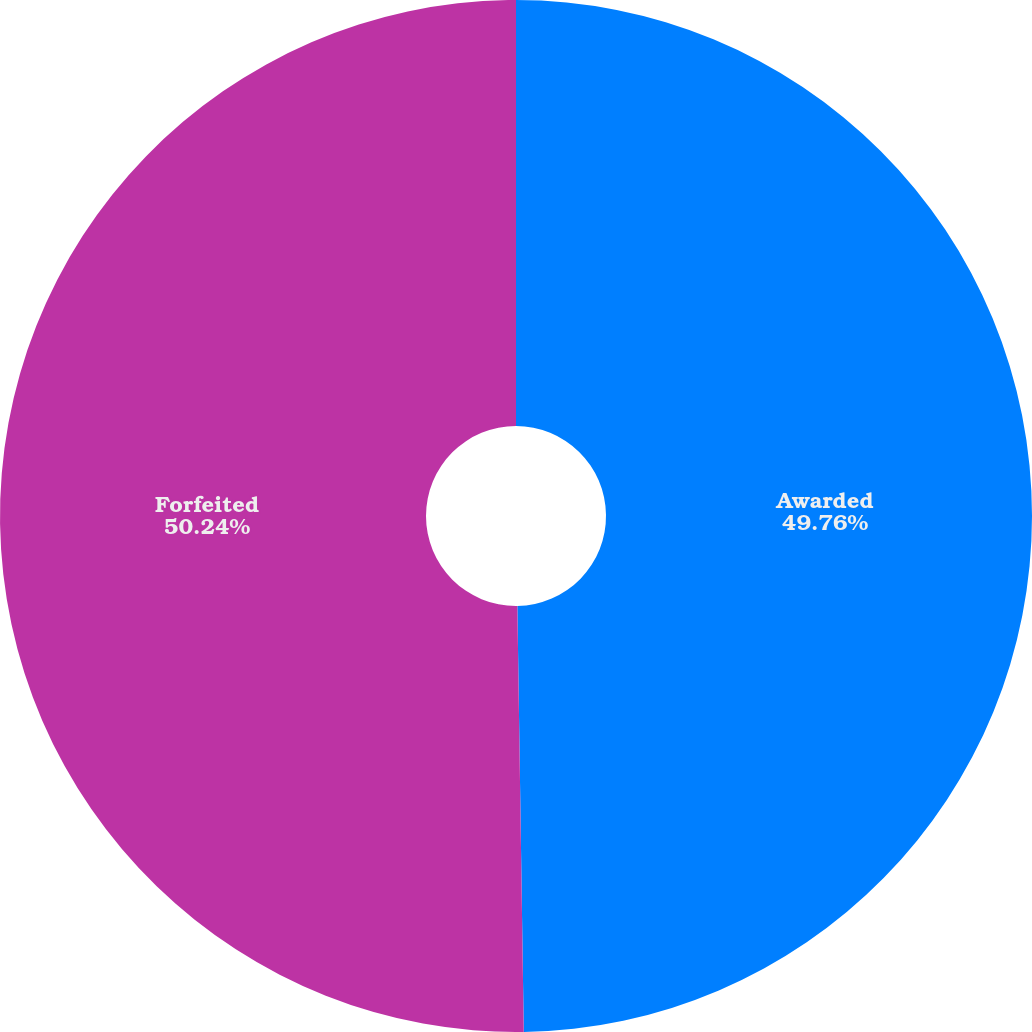Convert chart. <chart><loc_0><loc_0><loc_500><loc_500><pie_chart><fcel>Awarded<fcel>Forfeited<nl><fcel>49.76%<fcel>50.24%<nl></chart> 